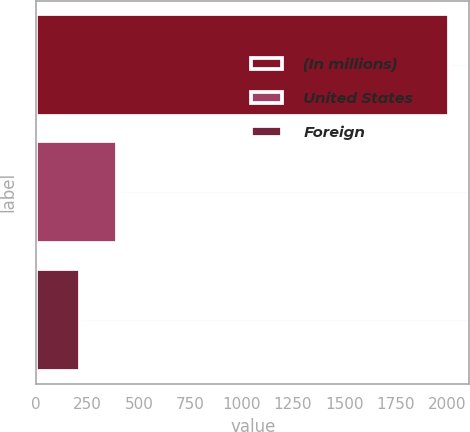<chart> <loc_0><loc_0><loc_500><loc_500><bar_chart><fcel>(In millions)<fcel>United States<fcel>Foreign<nl><fcel>2009<fcel>393.14<fcel>213.6<nl></chart> 